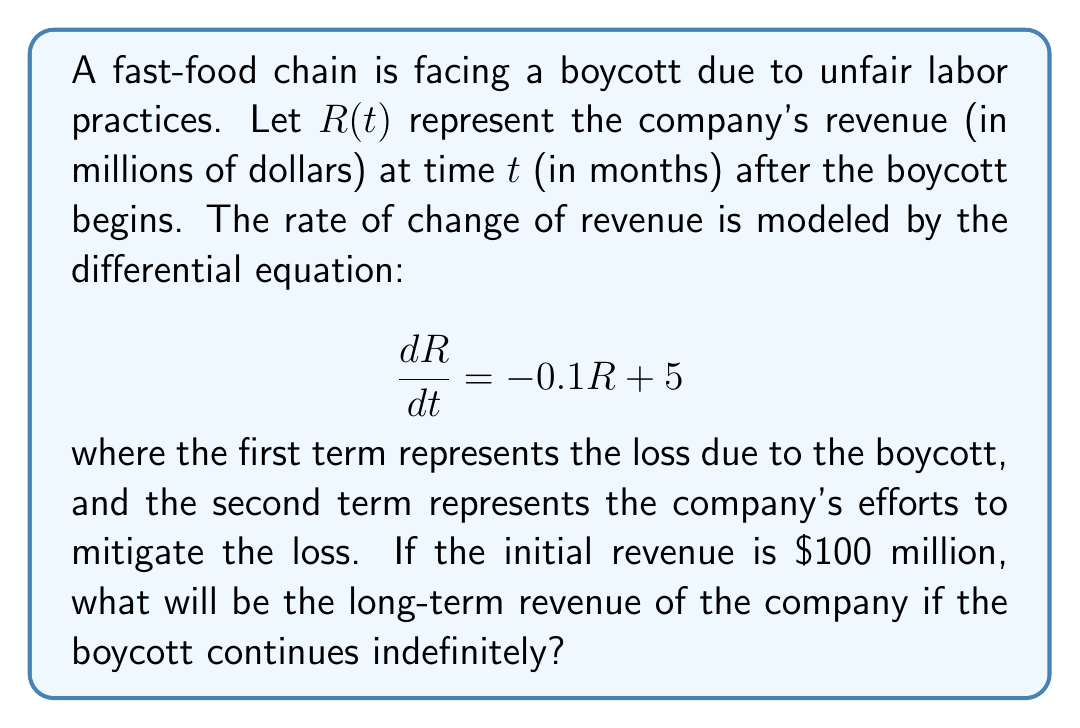Could you help me with this problem? To solve this problem, we need to follow these steps:

1) First, we recognize this as a linear first-order differential equation in the form:

   $$\frac{dR}{dt} + 0.1R = 5$$

2) The general solution for this type of equation is:

   $$R(t) = Ce^{-0.1t} + 50$$

   where $C$ is a constant and 50 is the particular solution (found by setting $\frac{dR}{dt} = 0$).

3) To find $C$, we use the initial condition $R(0) = 100$:

   $$100 = C + 50$$
   $$C = 50$$

4) So the specific solution is:

   $$R(t) = 50e^{-0.1t} + 50$$

5) To find the long-term revenue, we take the limit as $t$ approaches infinity:

   $$\lim_{t \to \infty} R(t) = \lim_{t \to \infty} (50e^{-0.1t} + 50)$$

6) As $t$ approaches infinity, $e^{-0.1t}$ approaches 0, so:

   $$\lim_{t \to \infty} R(t) = 0 + 50 = 50$$

Therefore, the long-term revenue of the company if the boycott continues indefinitely will be $50 million.
Answer: $50 million 